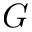Convert formula to latex. <formula><loc_0><loc_0><loc_500><loc_500>G</formula> 